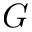Convert formula to latex. <formula><loc_0><loc_0><loc_500><loc_500>G</formula> 